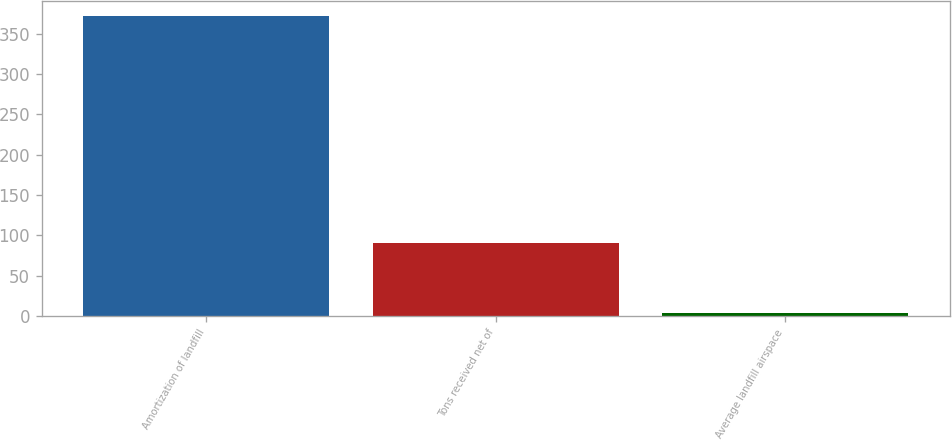Convert chart. <chart><loc_0><loc_0><loc_500><loc_500><bar_chart><fcel>Amortization of landfill<fcel>Tons received net of<fcel>Average landfill airspace<nl><fcel>372<fcel>91<fcel>4.08<nl></chart> 